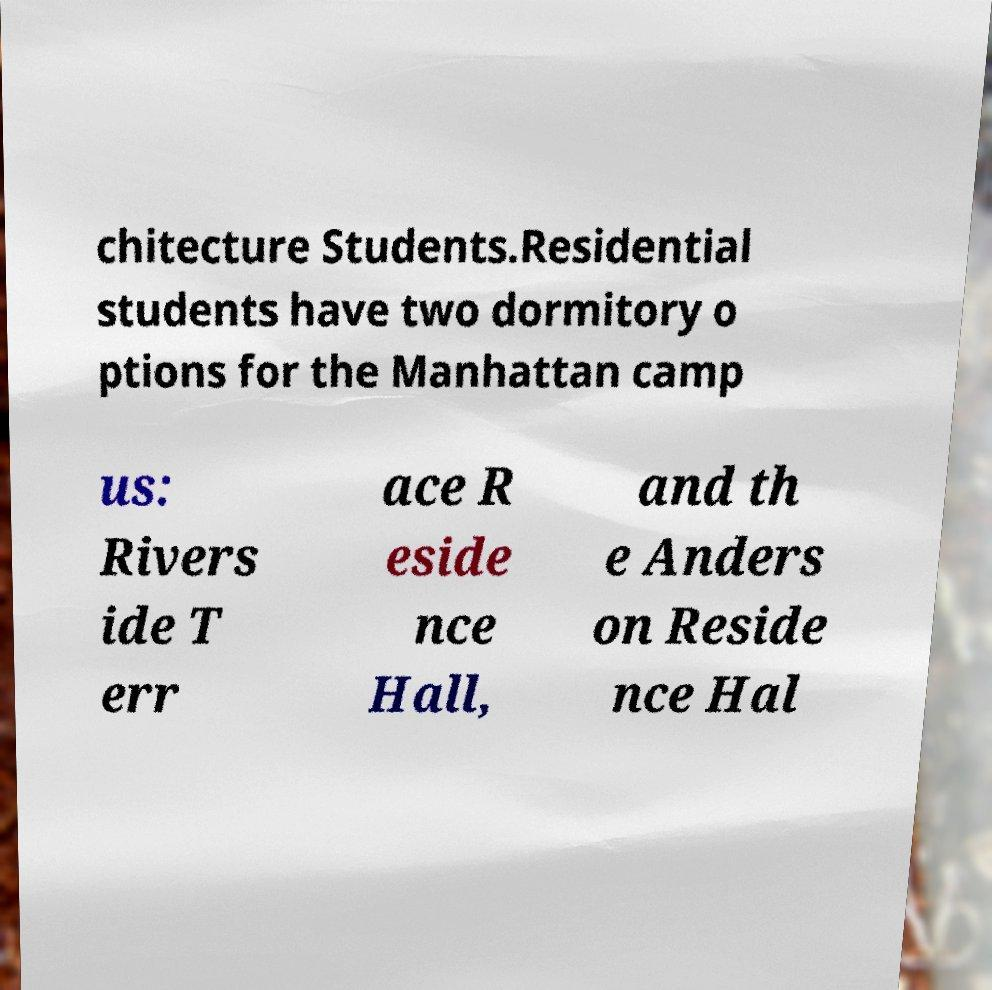I need the written content from this picture converted into text. Can you do that? chitecture Students.Residential students have two dormitory o ptions for the Manhattan camp us: Rivers ide T err ace R eside nce Hall, and th e Anders on Reside nce Hal 